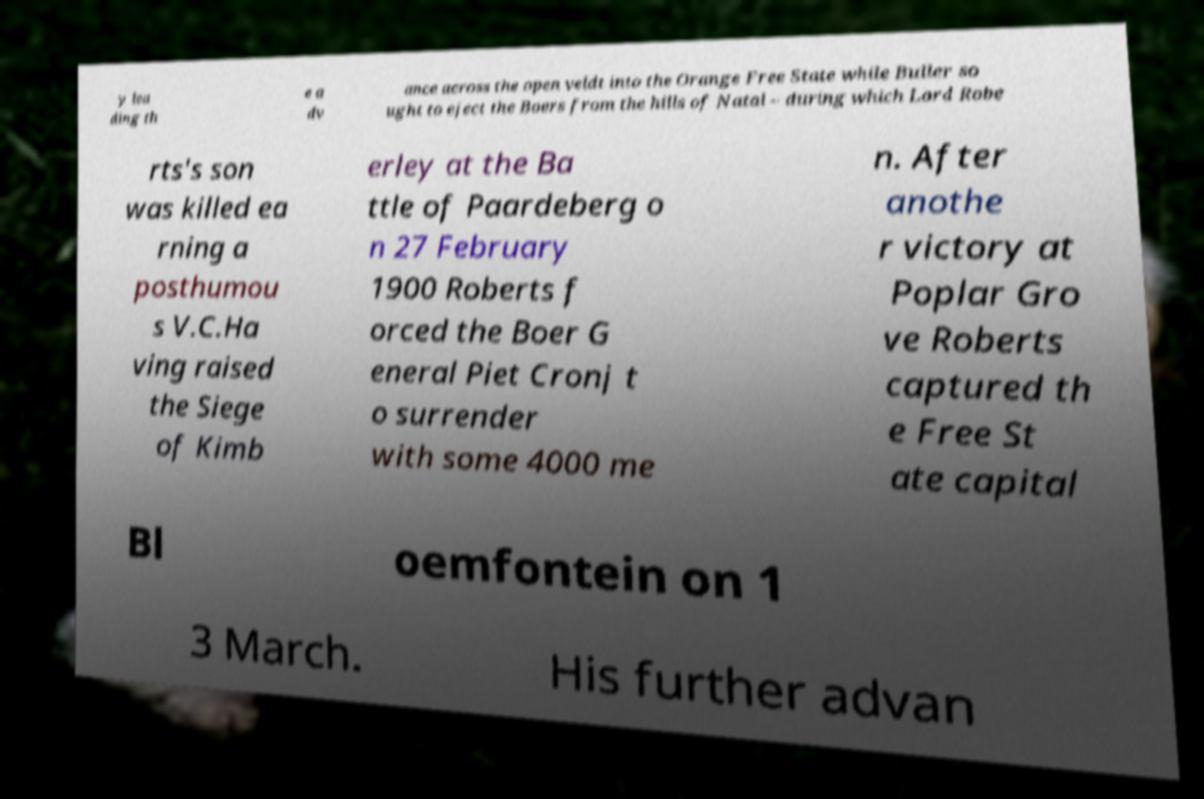Please read and relay the text visible in this image. What does it say? y lea ding th e a dv ance across the open veldt into the Orange Free State while Buller so ught to eject the Boers from the hills of Natal – during which Lord Robe rts's son was killed ea rning a posthumou s V.C.Ha ving raised the Siege of Kimb erley at the Ba ttle of Paardeberg o n 27 February 1900 Roberts f orced the Boer G eneral Piet Cronj t o surrender with some 4000 me n. After anothe r victory at Poplar Gro ve Roberts captured th e Free St ate capital Bl oemfontein on 1 3 March. His further advan 